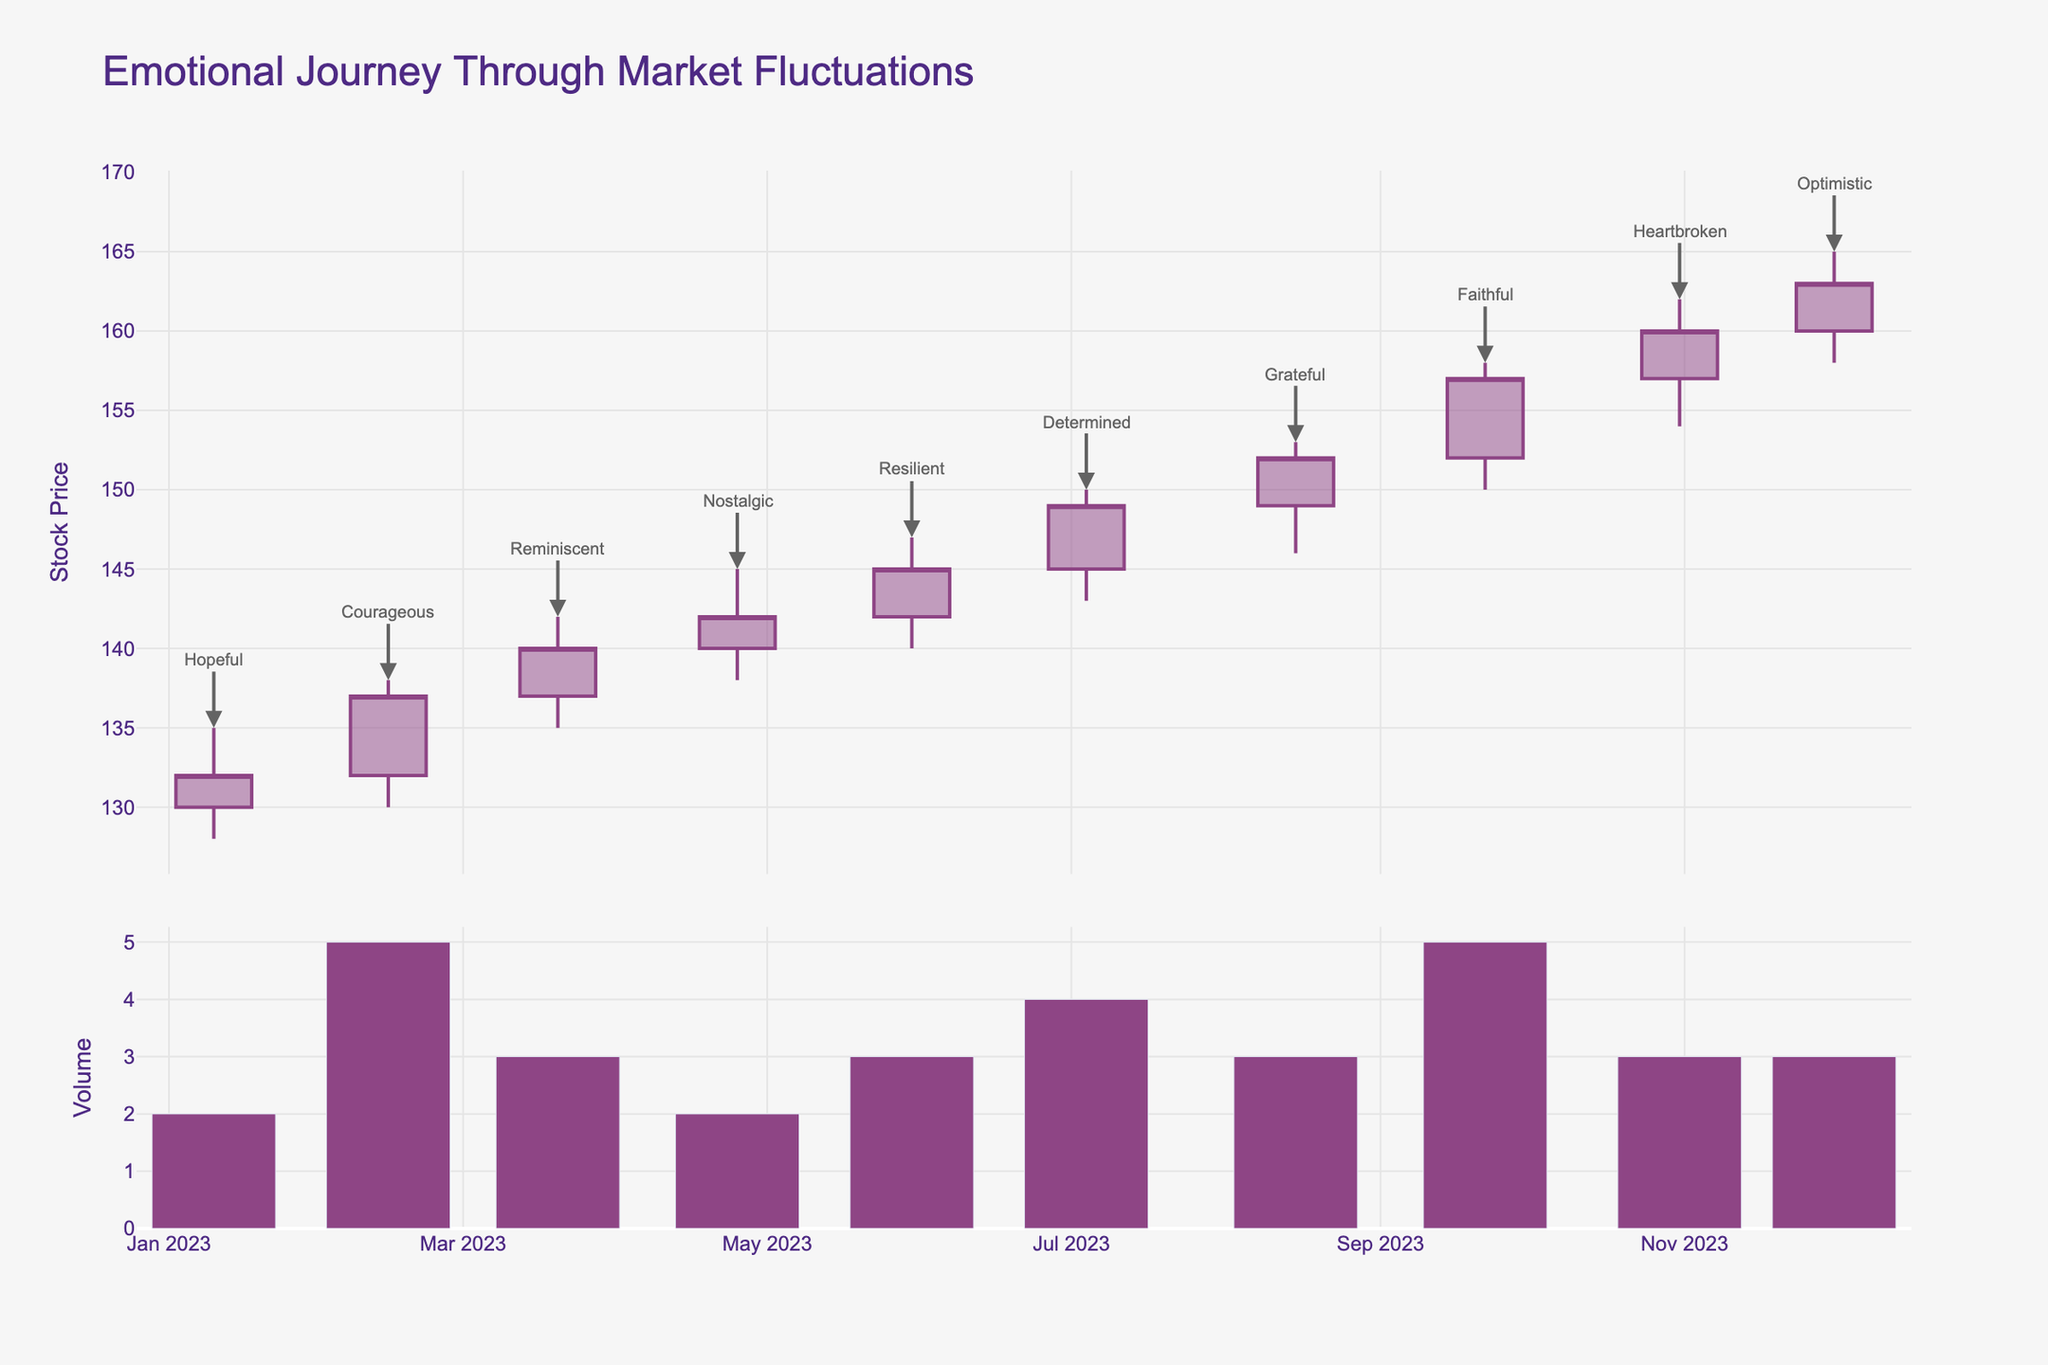What is the title of the plot? The title of the plot is written at the top and describes the overall theme being depicted.
Answer: Emotional Journey Through Market Fluctuations When did the stock price close at its highest value? Look for the tallest candlestick that represents the maximum closing value and check the associated date.
Answer: December 1, 2023 Which day's closing price showed the emotion "Heartbroken"? Examine the annotations near the candlesticks to find the one labeled "Heartbroken" and note the corresponding date.
Answer: October 31, 2023 What is the general trend of the stock prices from January to December? Observe the start and end points of the candlesticks from January to December, noting if prices are overall increasing or decreasing.
Answer: Increasing trend How much did the stock price increase from January 10 to February 14? Subtract the closing price of January 10 from the closing price of February 14.
Answer: 5.0 What was the emotion on the date with the lowest high value in the chart? Identify the candlestick with the lowest high value and check the corresponding emotion annotation.
Answer: Hopeful Which date experienced the largest difference between open and close prices? Calculate the difference between open and close for each date and identify the date with the maximum difference.
Answer: February 14, 2023 How does the volume trend compare between the dates exhibiting "Resilient" and "Determined"? Compare the bar lengths underneath the candlestick plots labeled "Resilient" (May 30) and "Determined" (July 4) to see which is longer.
Answer: Volume is higher on May 30 Which two emotions are associated with the two highest closing values? Identify the highest and second highest closing values and check the corresponding emotional annotations.
Answer: Optimistic and Faithful By how much did the stock price change between August 15 and September 22? Subtract the closing price of August 15 from the closing price of September 22.
Answer: 5.0 